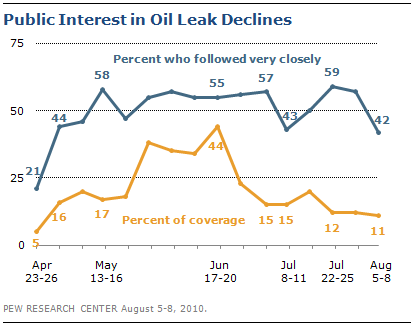Give some essential details in this illustration. Of the orange data points, how many have a value of 15? The value of the blue line is always greater than the orange line. 